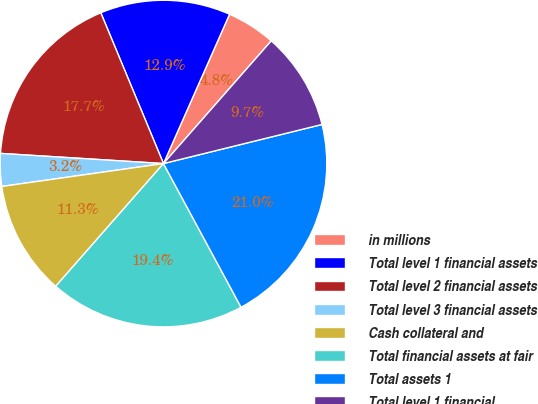Convert chart. <chart><loc_0><loc_0><loc_500><loc_500><pie_chart><fcel>in millions<fcel>Total level 1 financial assets<fcel>Total level 2 financial assets<fcel>Total level 3 financial assets<fcel>Cash collateral and<fcel>Total financial assets at fair<fcel>Total assets 1<fcel>Total level 1 financial<nl><fcel>4.84%<fcel>12.9%<fcel>17.74%<fcel>3.23%<fcel>11.29%<fcel>19.35%<fcel>20.97%<fcel>9.68%<nl></chart> 